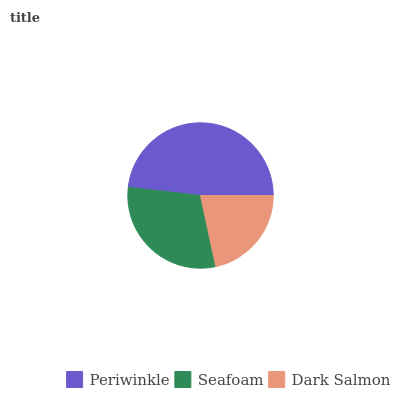Is Dark Salmon the minimum?
Answer yes or no. Yes. Is Periwinkle the maximum?
Answer yes or no. Yes. Is Seafoam the minimum?
Answer yes or no. No. Is Seafoam the maximum?
Answer yes or no. No. Is Periwinkle greater than Seafoam?
Answer yes or no. Yes. Is Seafoam less than Periwinkle?
Answer yes or no. Yes. Is Seafoam greater than Periwinkle?
Answer yes or no. No. Is Periwinkle less than Seafoam?
Answer yes or no. No. Is Seafoam the high median?
Answer yes or no. Yes. Is Seafoam the low median?
Answer yes or no. Yes. Is Periwinkle the high median?
Answer yes or no. No. Is Dark Salmon the low median?
Answer yes or no. No. 